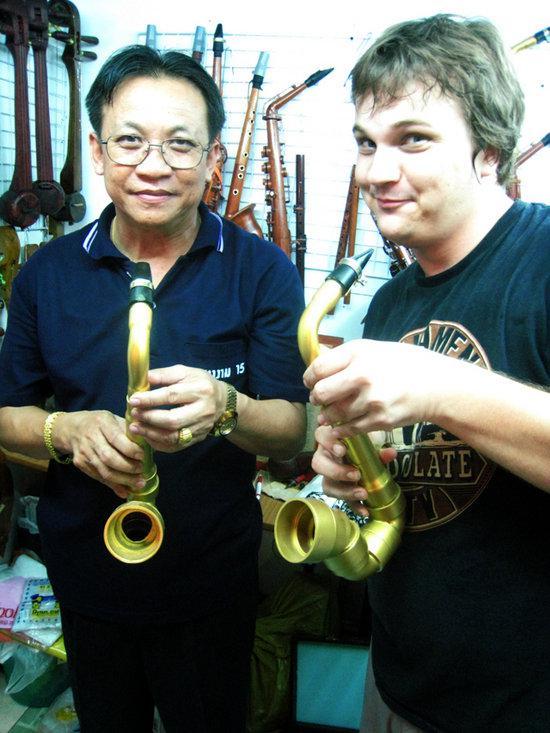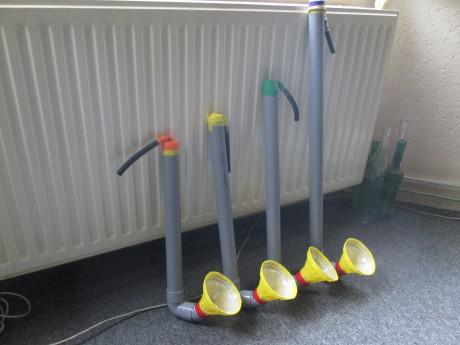The first image is the image on the left, the second image is the image on the right. Given the left and right images, does the statement "Two people can be seen holding a musical instrument." hold true? Answer yes or no. Yes. 